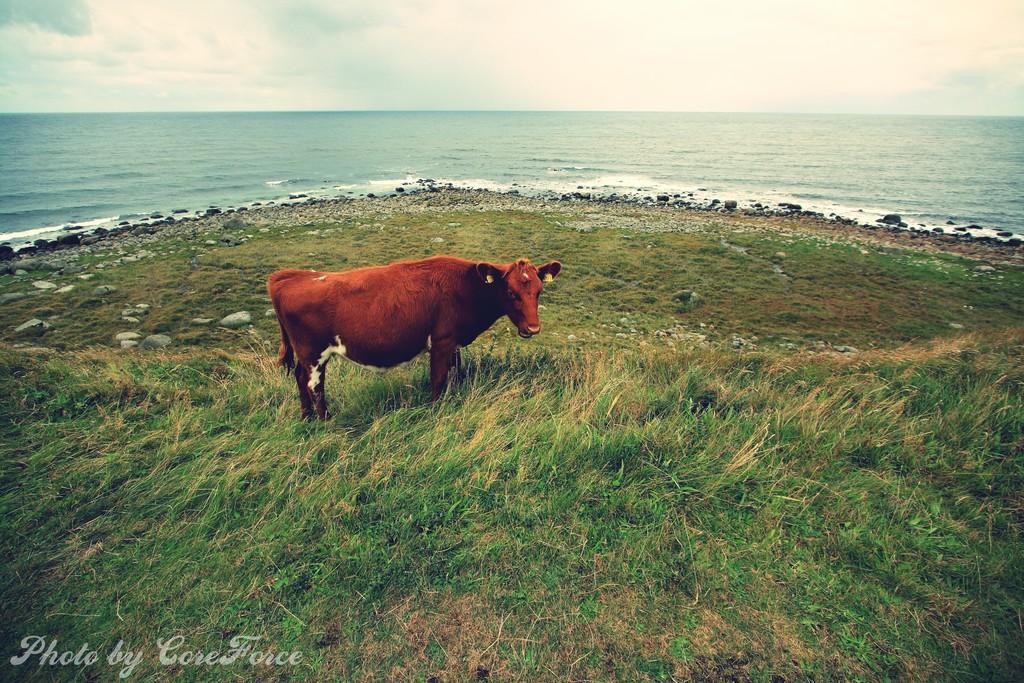Please provide a concise description of this image. There is a cow standing on the grass. In the back there are rocks, water and sky. And there is a watermark on the right corner. 